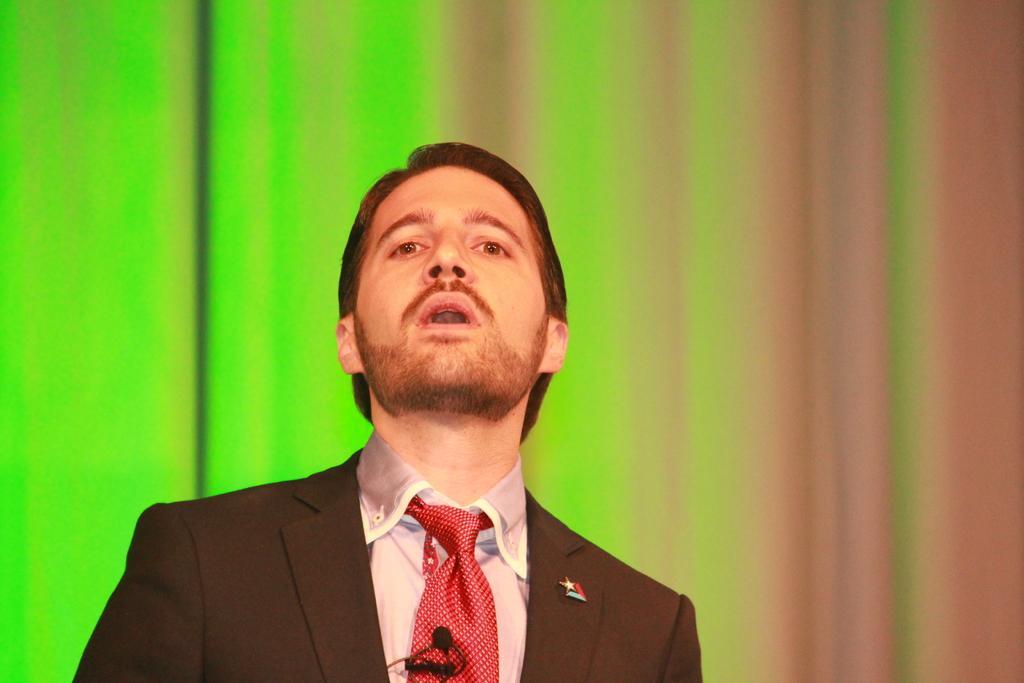Can you describe this image briefly? In the middle a man is raising his head, he wore coat, shirt, tie. 